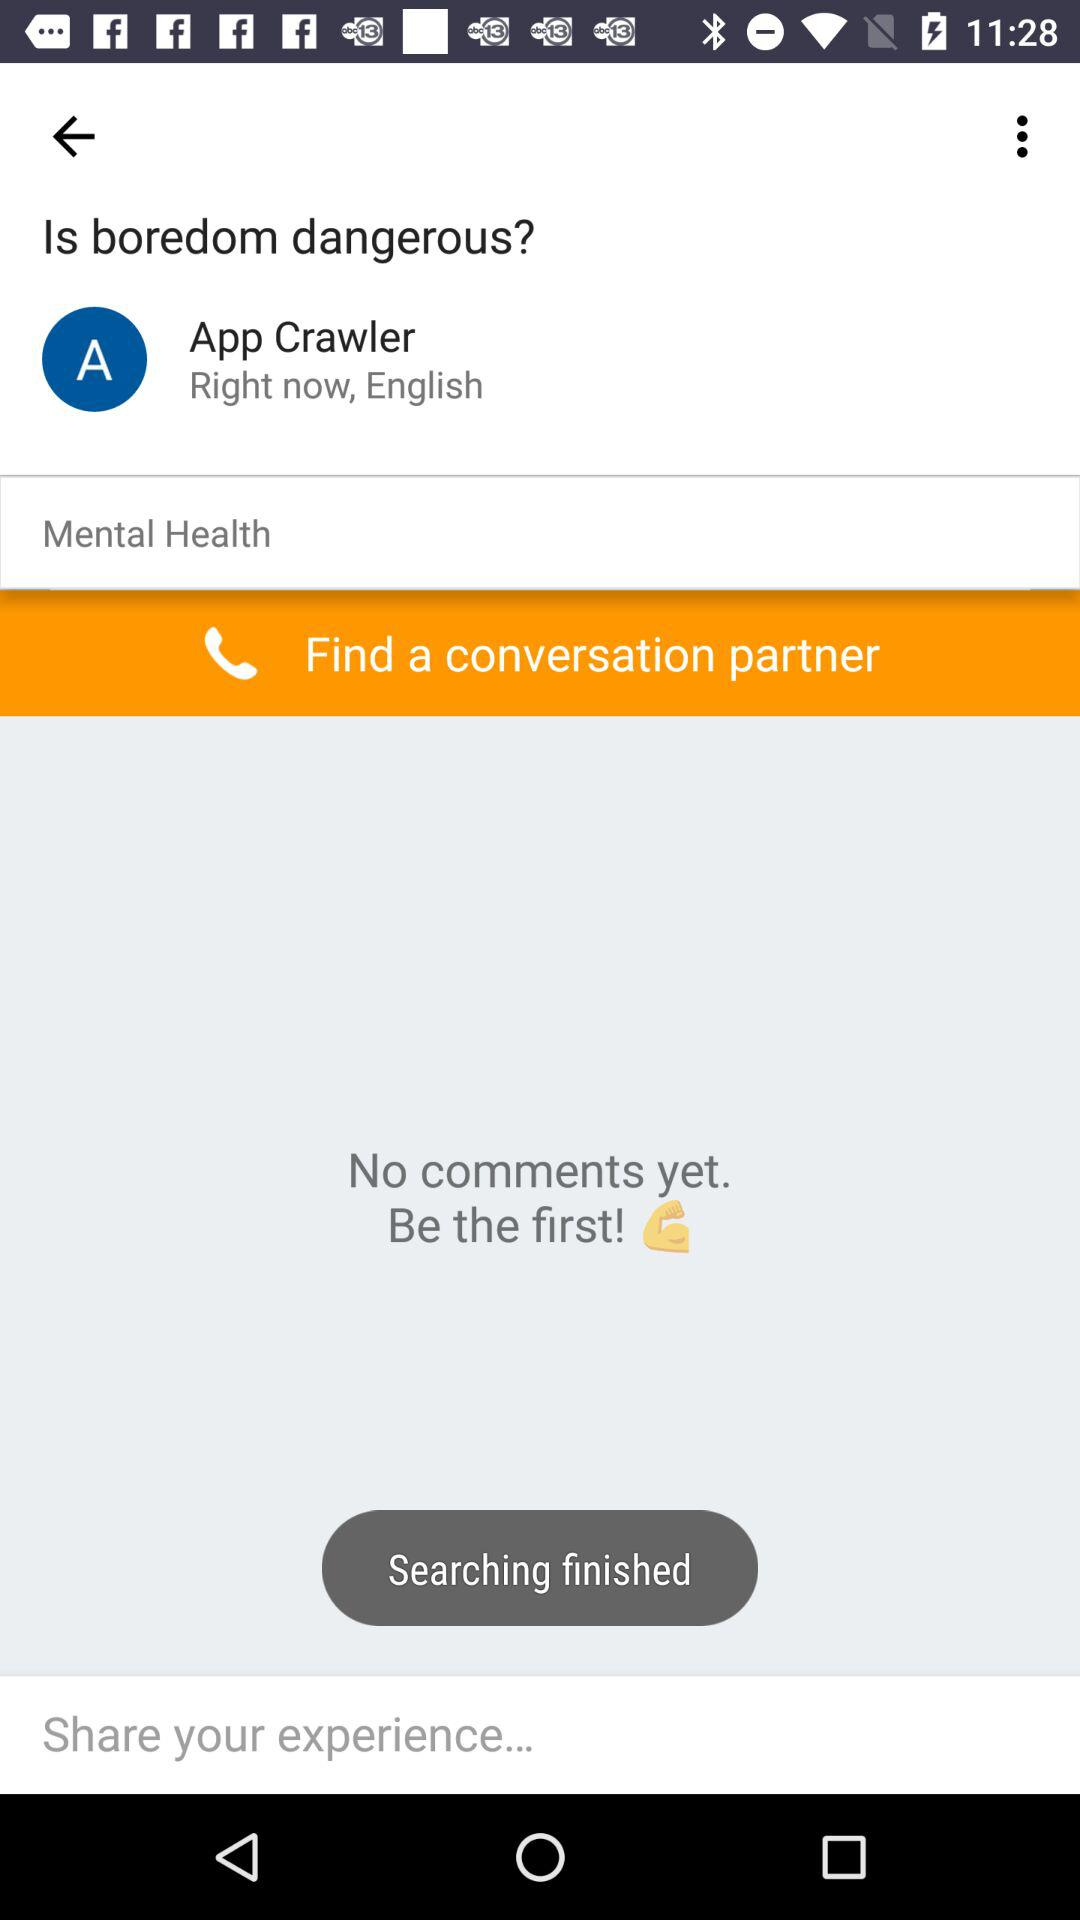What topic is being discussed in this app or forum? The topic being discussed is related to mental health, specifically questioning whether boredom can be dangerous. 